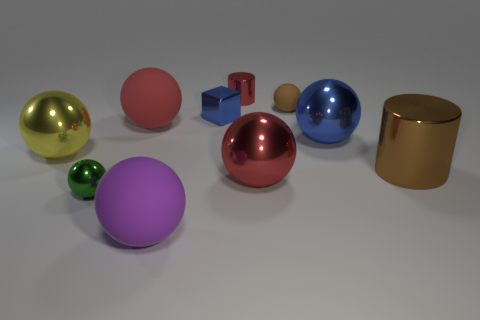What size is the brown rubber sphere?
Keep it short and to the point. Small. There is a big ball that is made of the same material as the purple thing; what color is it?
Your response must be concise. Red. What number of other blue blocks have the same size as the cube?
Give a very brief answer. 0. Do the tiny thing that is behind the tiny brown thing and the yellow object have the same material?
Offer a very short reply. Yes. Is the number of big red rubber spheres on the left side of the yellow object less than the number of brown objects?
Make the answer very short. Yes. What is the shape of the large metal object left of the red shiny ball?
Make the answer very short. Sphere. There is a purple matte thing that is the same size as the brown metallic cylinder; what shape is it?
Make the answer very short. Sphere. Is there a blue shiny thing of the same shape as the purple thing?
Your answer should be very brief. Yes. Does the large matte thing that is in front of the green thing have the same shape as the brown object that is on the left side of the brown cylinder?
Offer a terse response. Yes. What material is the brown object that is the same size as the shiny block?
Give a very brief answer. Rubber. 